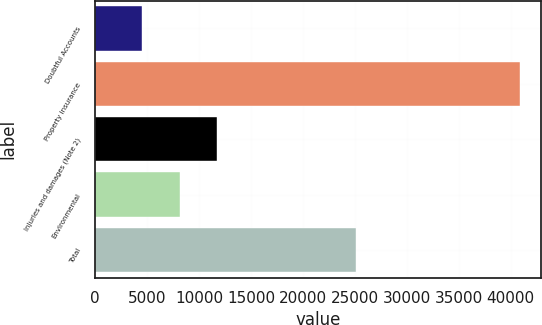<chart> <loc_0><loc_0><loc_500><loc_500><bar_chart><fcel>Doubtful Accounts<fcel>Property insurance<fcel>Injuries and damages (Note 2)<fcel>Environmental<fcel>Total<nl><fcel>4487<fcel>40878<fcel>11765.2<fcel>8126.1<fcel>25096<nl></chart> 